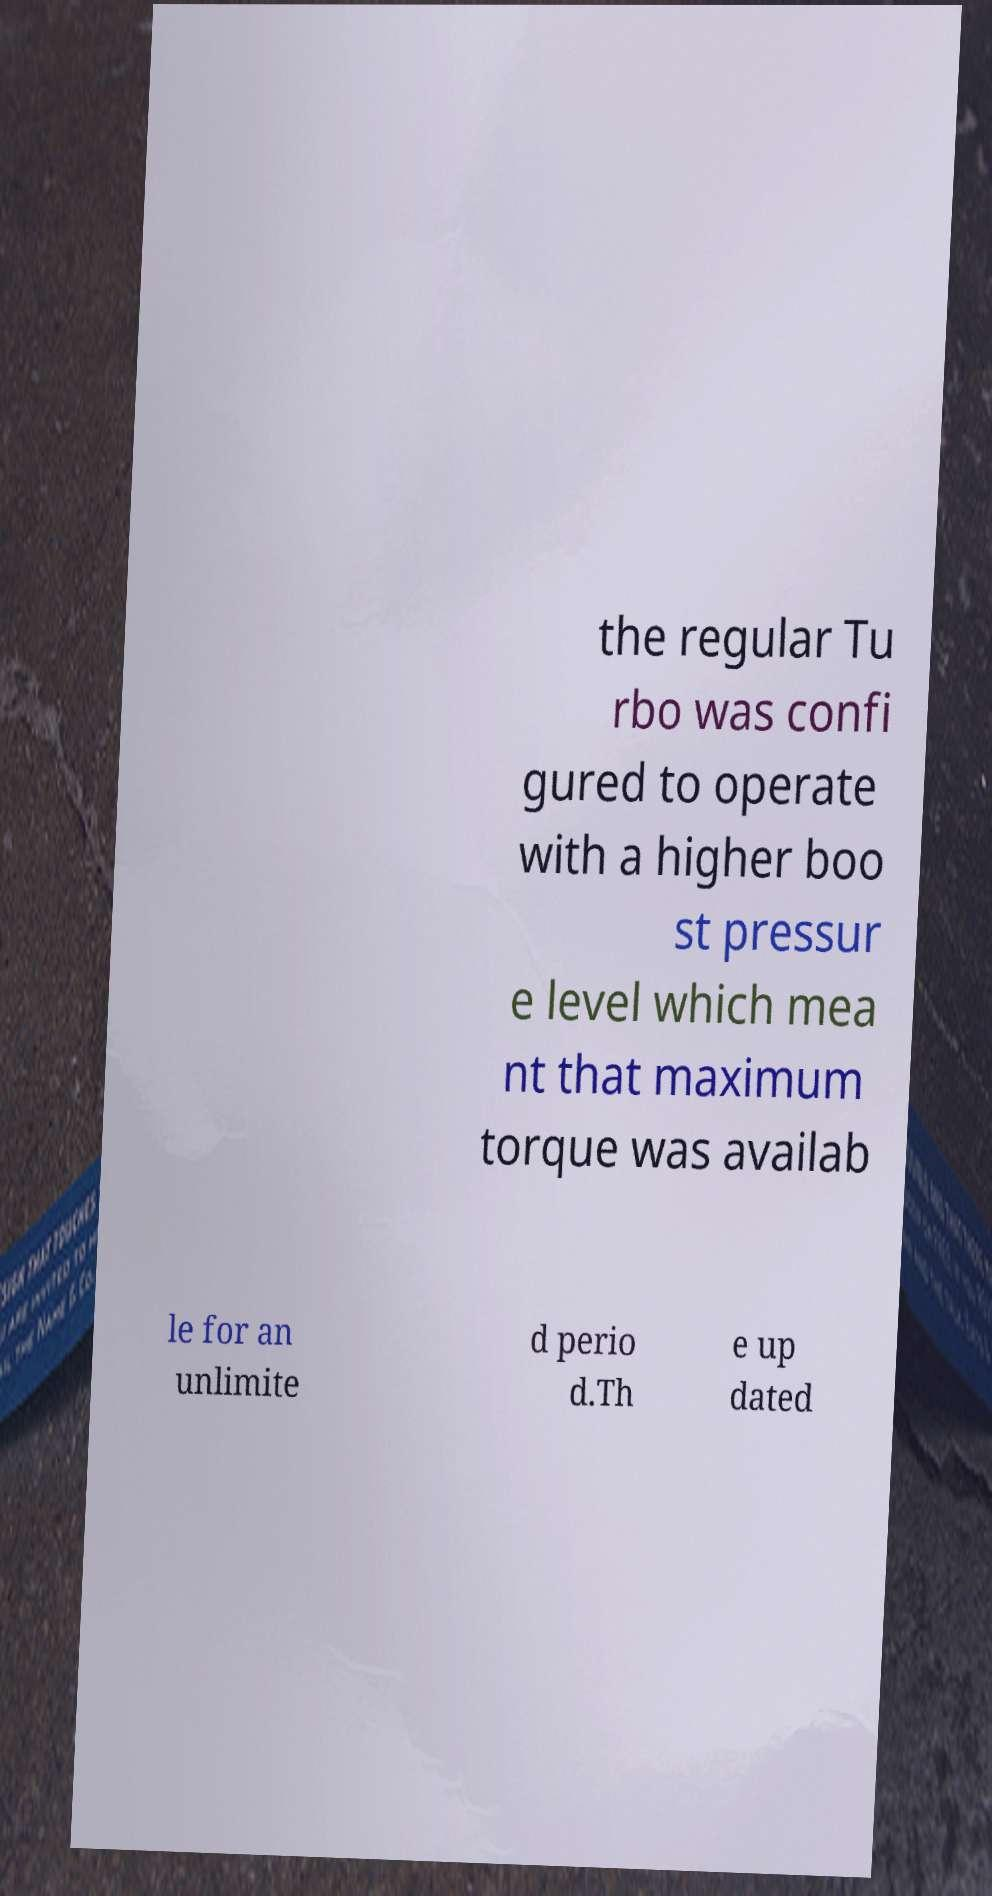Can you accurately transcribe the text from the provided image for me? the regular Tu rbo was confi gured to operate with a higher boo st pressur e level which mea nt that maximum torque was availab le for an unlimite d perio d.Th e up dated 